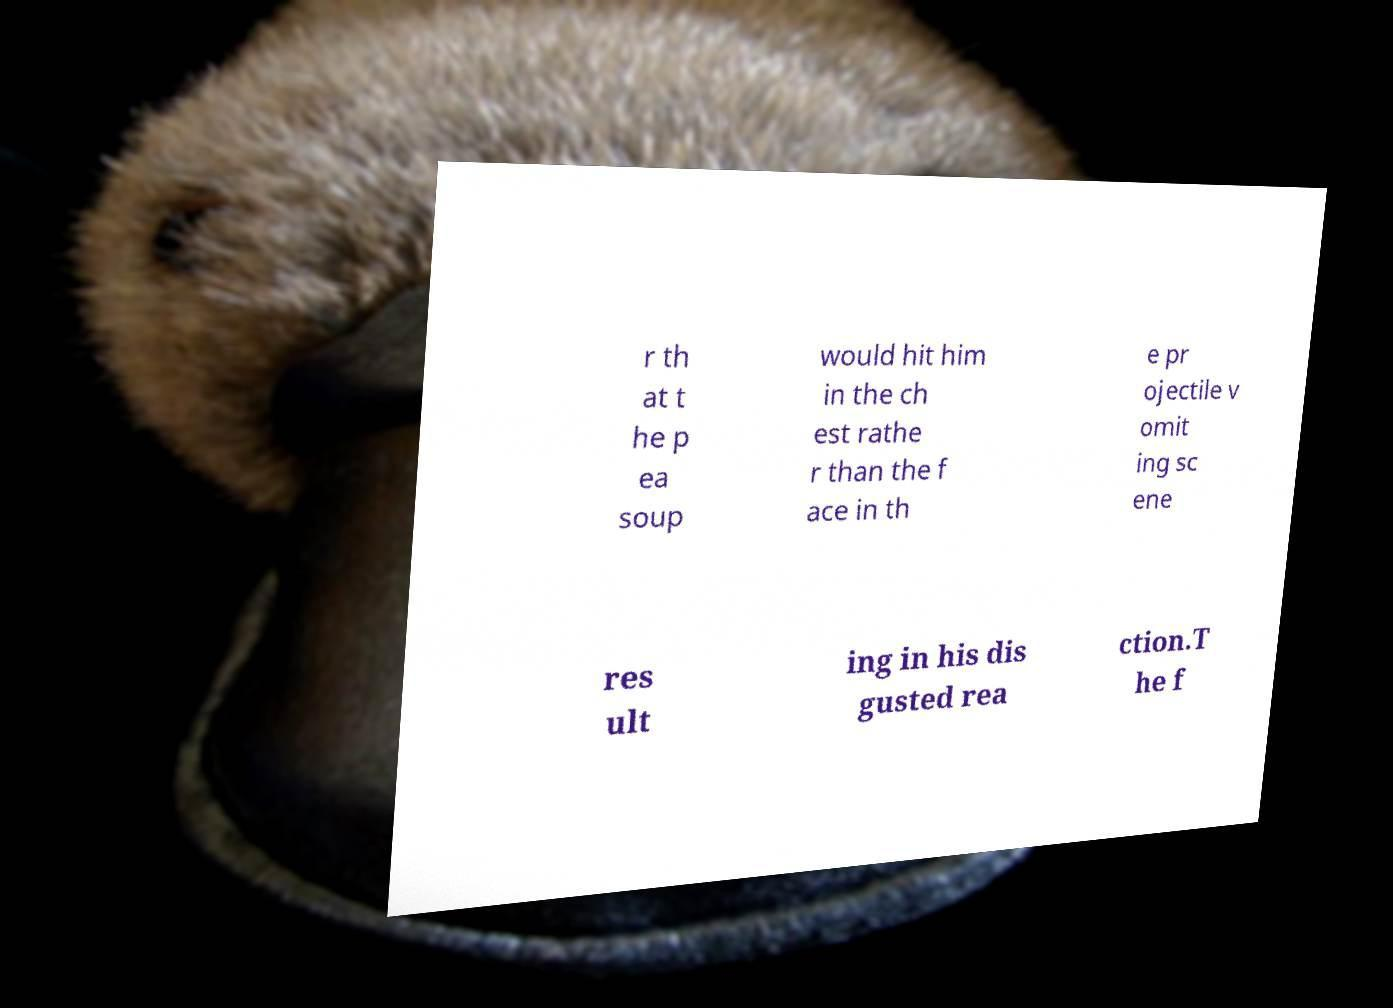There's text embedded in this image that I need extracted. Can you transcribe it verbatim? r th at t he p ea soup would hit him in the ch est rathe r than the f ace in th e pr ojectile v omit ing sc ene res ult ing in his dis gusted rea ction.T he f 